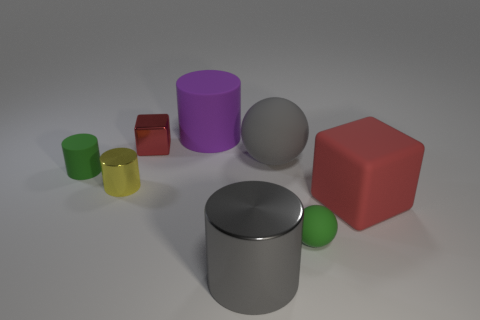Subtract all large purple cylinders. How many cylinders are left? 3 Subtract all purple cylinders. How many cylinders are left? 3 Add 2 tiny green objects. How many objects exist? 10 Subtract all cubes. How many objects are left? 6 Subtract 1 cylinders. How many cylinders are left? 3 Subtract all gray balls. Subtract all cyan cubes. How many balls are left? 1 Subtract all blue balls. How many brown cylinders are left? 0 Subtract all large gray things. Subtract all tiny spheres. How many objects are left? 5 Add 2 shiny cylinders. How many shiny cylinders are left? 4 Add 5 small green matte spheres. How many small green matte spheres exist? 6 